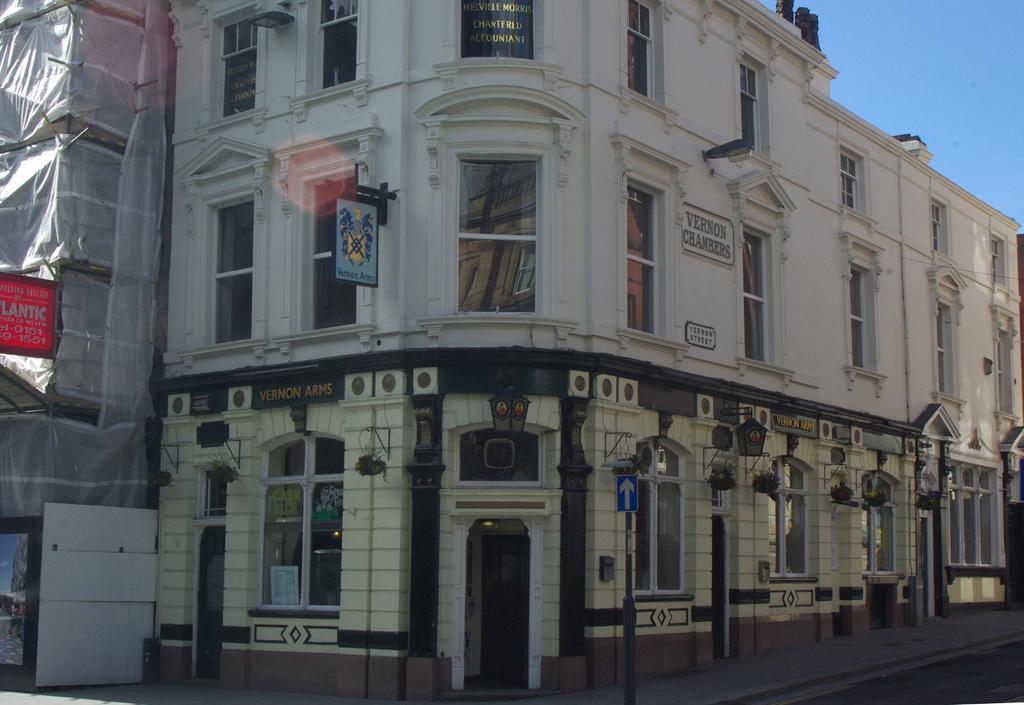Can you describe this image briefly? The picture consists of buildings, windows, door, boards and a cover. Sky is sunny. 